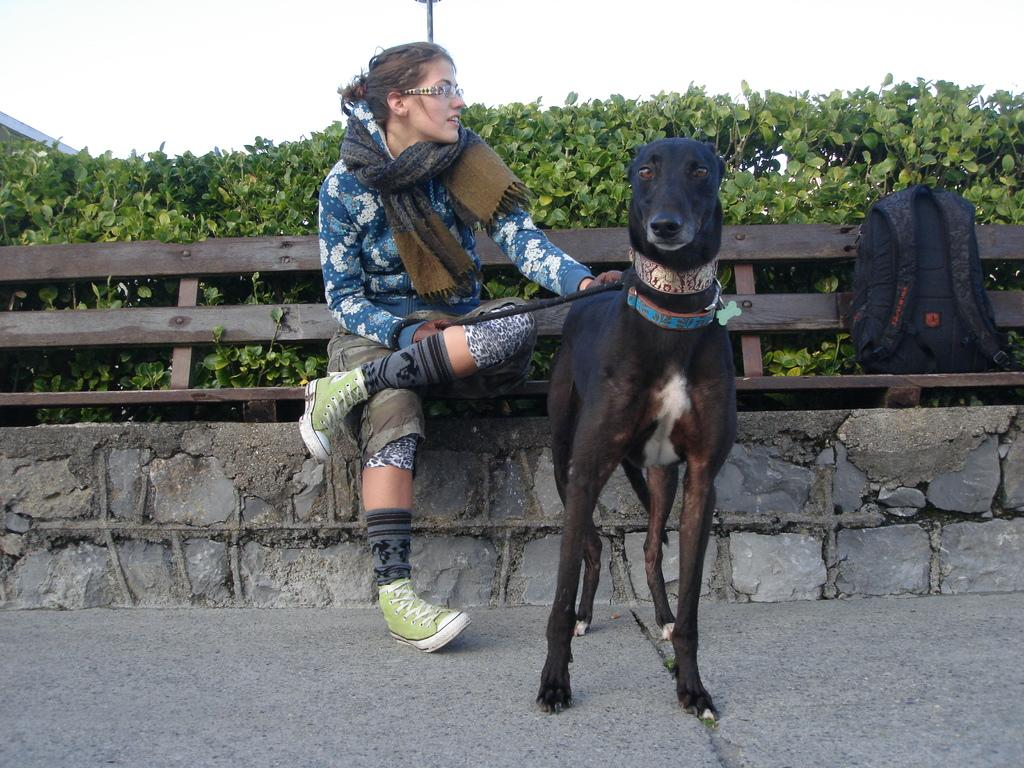What type of animal can be seen in the image? There is a dog in the image. What is the girl doing in the image? The girl is sitting on a bench in the image. What can be seen on the right side of the image? There is a bag on the right side of the image. What type of vegetation is visible in the image? There are plants visible in the image. What structure can be seen at the back of the image? There is a pole at the back of the image. How many houses are visible in the image? There are no houses visible in the image. What shape is the alarm in the image? There is no alarm present in the image. 